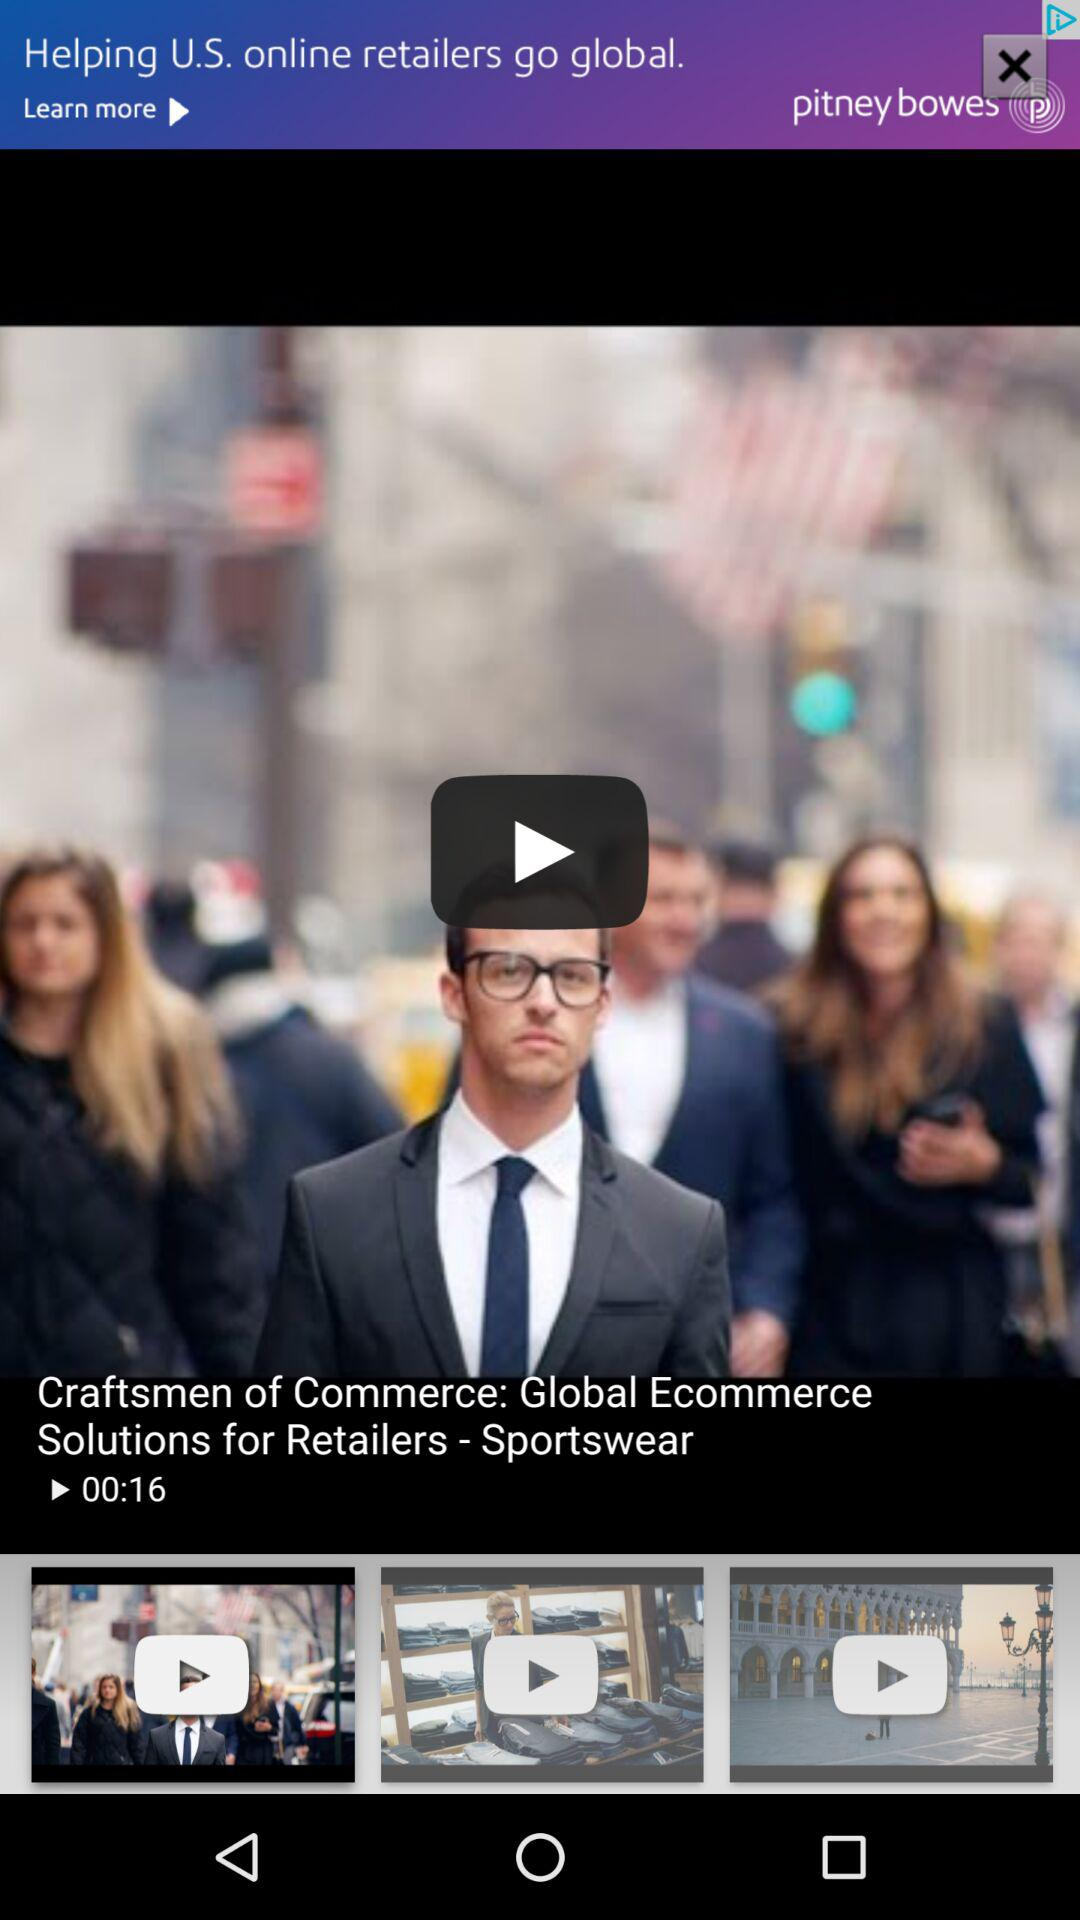What is the name of the video? The name of the video is "Craftsmen of Commerce: Global Ecommerce Solutions for Retailers-Sportswear". 